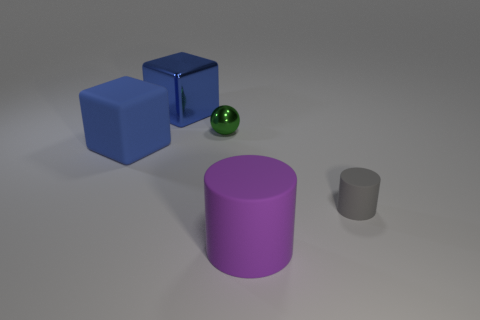There is a cylinder that is behind the big purple cylinder; what size is it?
Your response must be concise. Small. There is a blue matte thing that is the same size as the blue metal object; what shape is it?
Your response must be concise. Cube. Is the object that is to the left of the large shiny cube made of the same material as the large object that is right of the small metal thing?
Your answer should be compact. Yes. What material is the large cube on the left side of the blue block that is behind the small ball made of?
Your response must be concise. Rubber. What is the size of the rubber object to the right of the big purple object right of the blue object that is in front of the metal ball?
Give a very brief answer. Small. Is the size of the green object the same as the gray rubber cylinder?
Ensure brevity in your answer.  Yes. There is a big rubber object that is on the right side of the big blue matte cube; is it the same shape as the tiny thing on the right side of the metallic sphere?
Provide a short and direct response. Yes. Are there any purple rubber cylinders that are on the left side of the large blue thing on the right side of the large rubber cube?
Offer a very short reply. No. Are there any big purple rubber balls?
Your answer should be very brief. No. How many blue cubes are the same size as the blue matte thing?
Your response must be concise. 1. 